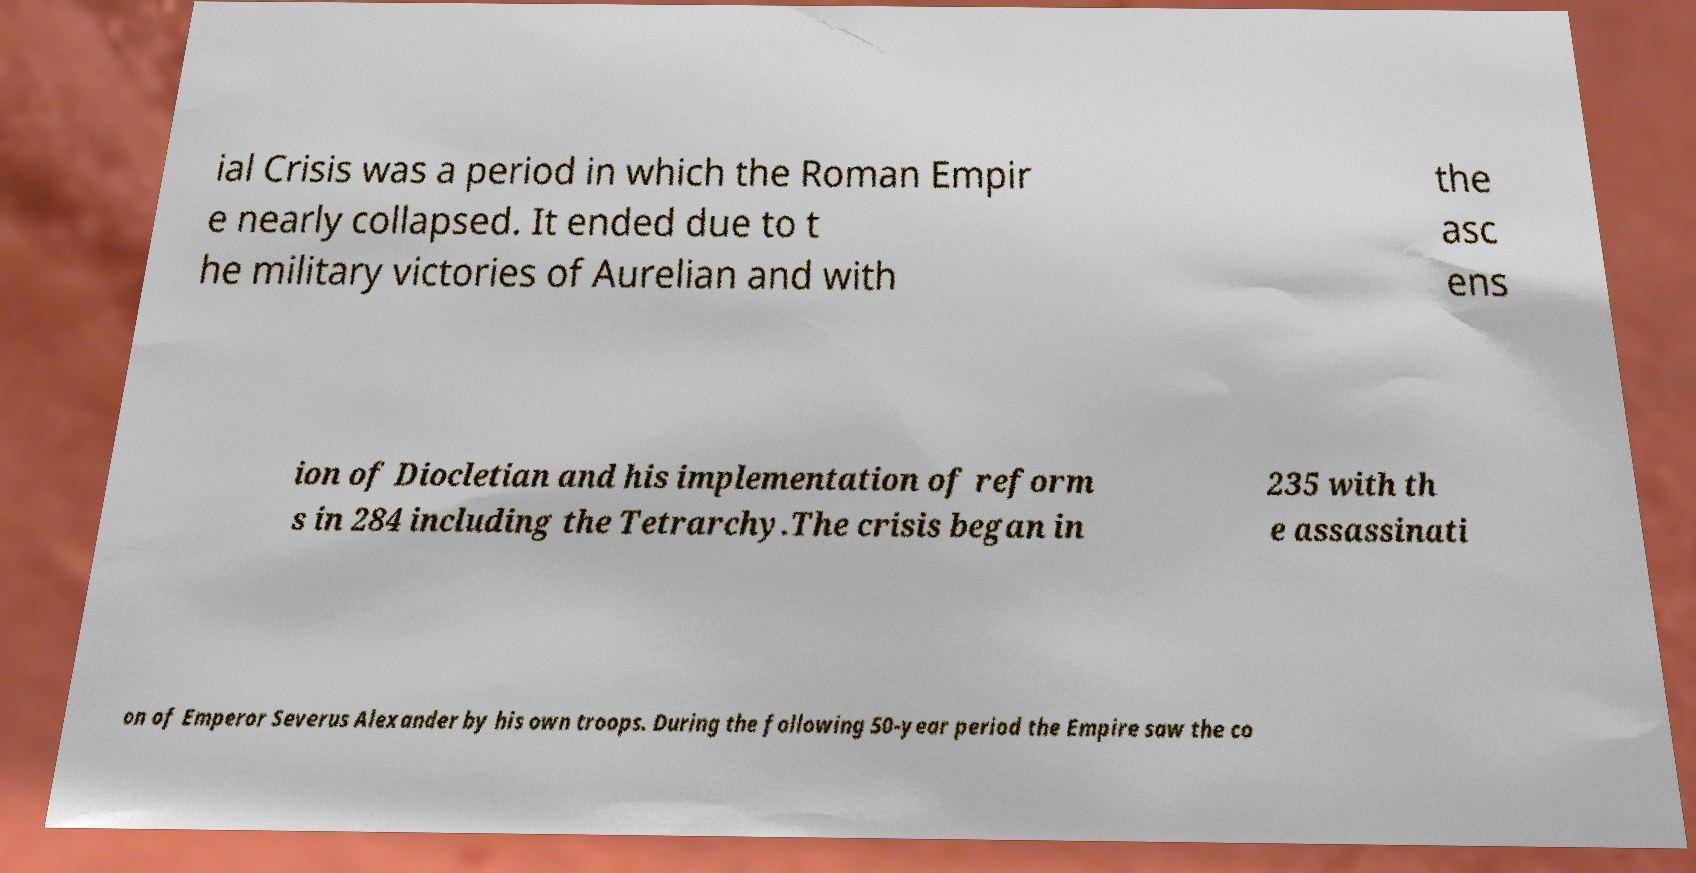Could you assist in decoding the text presented in this image and type it out clearly? ial Crisis was a period in which the Roman Empir e nearly collapsed. It ended due to t he military victories of Aurelian and with the asc ens ion of Diocletian and his implementation of reform s in 284 including the Tetrarchy.The crisis began in 235 with th e assassinati on of Emperor Severus Alexander by his own troops. During the following 50-year period the Empire saw the co 